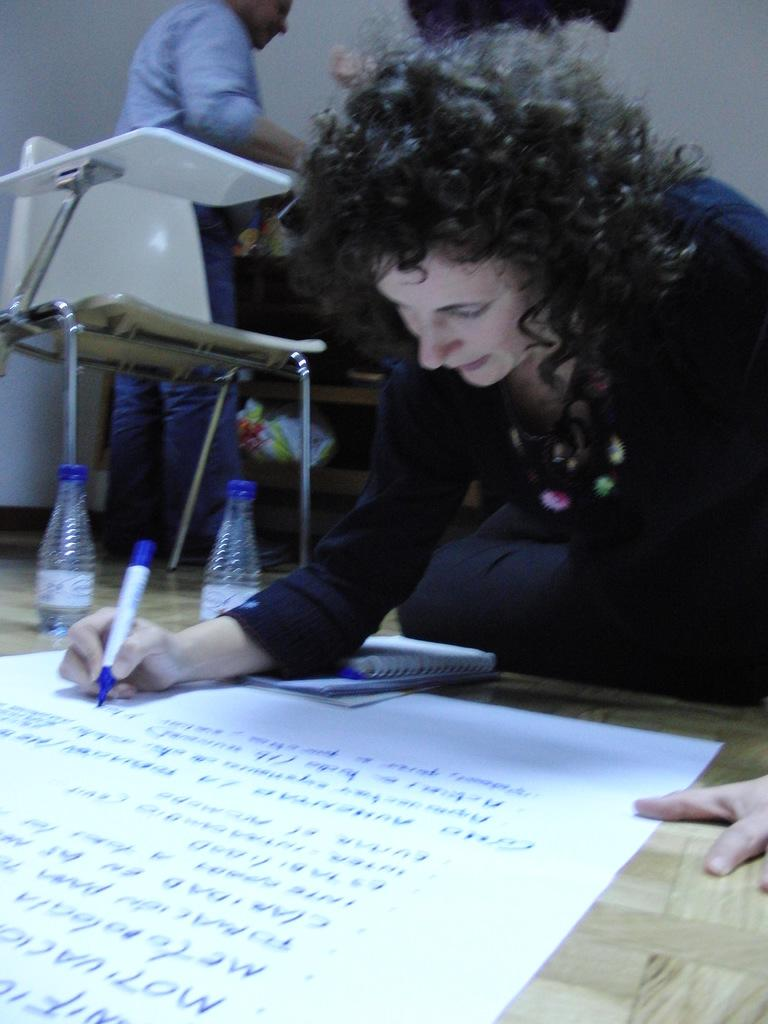How many people are present in the image? There are two people in the image. What object can be used for sitting in the image? There is a chair in the image. What type of containers are visible in the image? There are bottles in the image. What color is the wall in the image? The wall in the image is white. What activity is the woman engaged in? A woman is writing on a white color sheet. Can you hear thunder in the image? There is no mention of thunder in the image. 